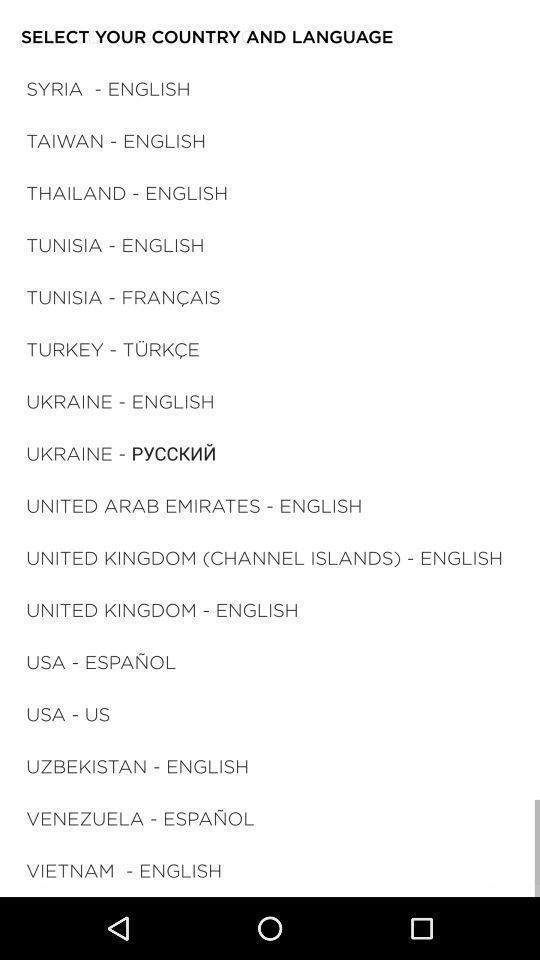Give me a narrative description of this picture. Page displaying with list of countries and select your language. 